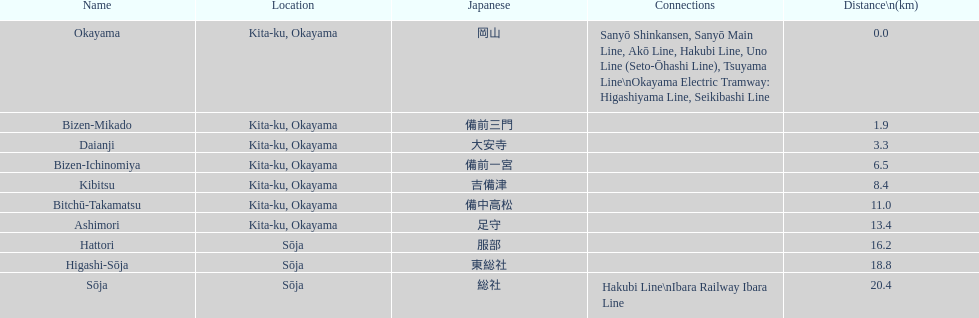Name only the stations that have connections to other lines. Okayama, Sōja. 